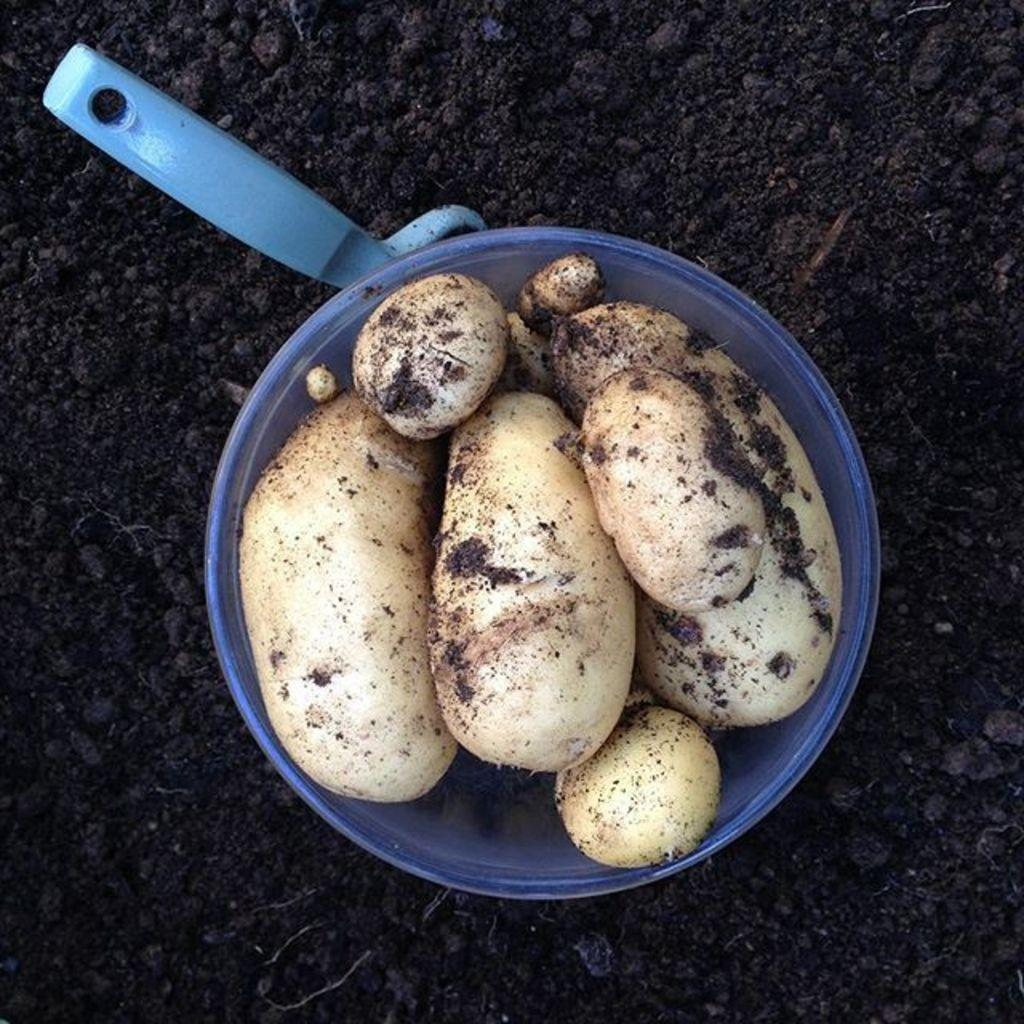What type of vegetables are in the bucket in the image? There are root vegetables in a bucket in the image. Where is the bucket located? The bucket is on the ground. What else can be seen on the ground beside the bucket? There is an object on the ground beside the bucket. How many babies are playing with dolls in the image? There are no babies or dolls present in the image; it features a bucket of root vegetables and an unspecified object on the ground. 